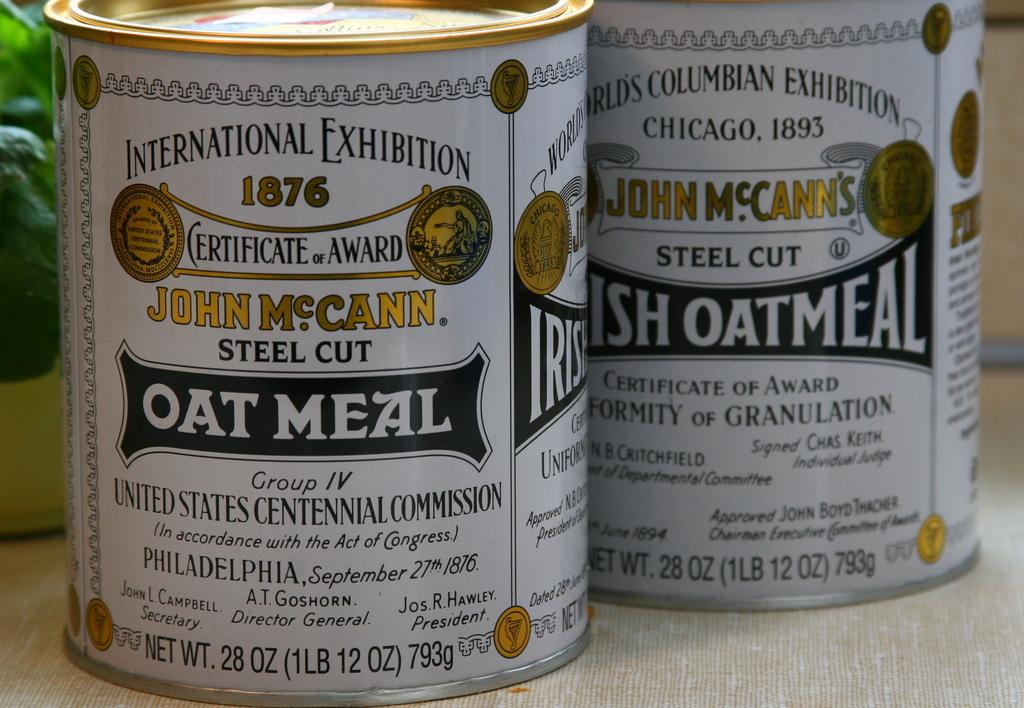<image>
Share a concise interpretation of the image provided. Two cans on a counter for John McCann Steel Cut Oatmeal. 